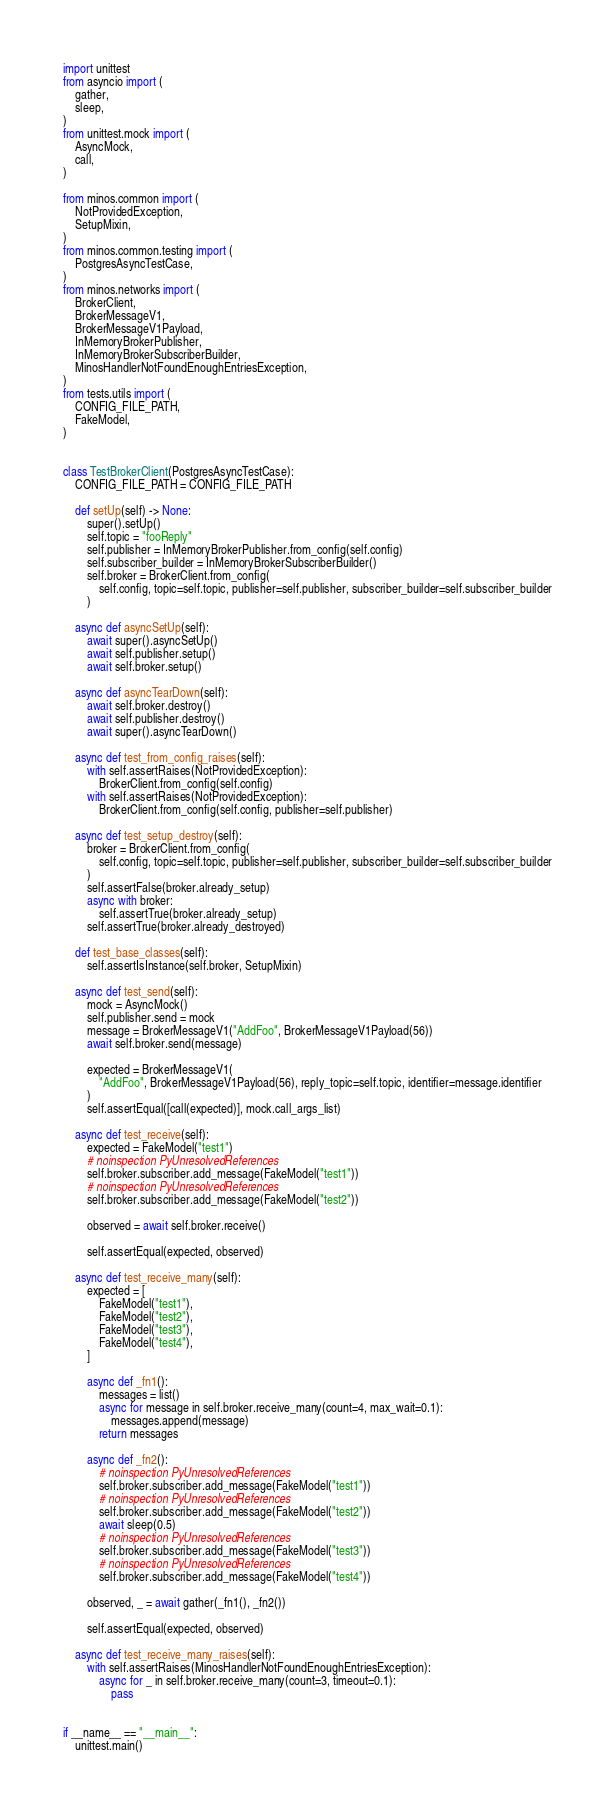<code> <loc_0><loc_0><loc_500><loc_500><_Python_>import unittest
from asyncio import (
    gather,
    sleep,
)
from unittest.mock import (
    AsyncMock,
    call,
)

from minos.common import (
    NotProvidedException,
    SetupMixin,
)
from minos.common.testing import (
    PostgresAsyncTestCase,
)
from minos.networks import (
    BrokerClient,
    BrokerMessageV1,
    BrokerMessageV1Payload,
    InMemoryBrokerPublisher,
    InMemoryBrokerSubscriberBuilder,
    MinosHandlerNotFoundEnoughEntriesException,
)
from tests.utils import (
    CONFIG_FILE_PATH,
    FakeModel,
)


class TestBrokerClient(PostgresAsyncTestCase):
    CONFIG_FILE_PATH = CONFIG_FILE_PATH

    def setUp(self) -> None:
        super().setUp()
        self.topic = "fooReply"
        self.publisher = InMemoryBrokerPublisher.from_config(self.config)
        self.subscriber_builder = InMemoryBrokerSubscriberBuilder()
        self.broker = BrokerClient.from_config(
            self.config, topic=self.topic, publisher=self.publisher, subscriber_builder=self.subscriber_builder
        )

    async def asyncSetUp(self):
        await super().asyncSetUp()
        await self.publisher.setup()
        await self.broker.setup()

    async def asyncTearDown(self):
        await self.broker.destroy()
        await self.publisher.destroy()
        await super().asyncTearDown()

    async def test_from_config_raises(self):
        with self.assertRaises(NotProvidedException):
            BrokerClient.from_config(self.config)
        with self.assertRaises(NotProvidedException):
            BrokerClient.from_config(self.config, publisher=self.publisher)

    async def test_setup_destroy(self):
        broker = BrokerClient.from_config(
            self.config, topic=self.topic, publisher=self.publisher, subscriber_builder=self.subscriber_builder
        )
        self.assertFalse(broker.already_setup)
        async with broker:
            self.assertTrue(broker.already_setup)
        self.assertTrue(broker.already_destroyed)

    def test_base_classes(self):
        self.assertIsInstance(self.broker, SetupMixin)

    async def test_send(self):
        mock = AsyncMock()
        self.publisher.send = mock
        message = BrokerMessageV1("AddFoo", BrokerMessageV1Payload(56))
        await self.broker.send(message)

        expected = BrokerMessageV1(
            "AddFoo", BrokerMessageV1Payload(56), reply_topic=self.topic, identifier=message.identifier
        )
        self.assertEqual([call(expected)], mock.call_args_list)

    async def test_receive(self):
        expected = FakeModel("test1")
        # noinspection PyUnresolvedReferences
        self.broker.subscriber.add_message(FakeModel("test1"))
        # noinspection PyUnresolvedReferences
        self.broker.subscriber.add_message(FakeModel("test2"))

        observed = await self.broker.receive()

        self.assertEqual(expected, observed)

    async def test_receive_many(self):
        expected = [
            FakeModel("test1"),
            FakeModel("test2"),
            FakeModel("test3"),
            FakeModel("test4"),
        ]

        async def _fn1():
            messages = list()
            async for message in self.broker.receive_many(count=4, max_wait=0.1):
                messages.append(message)
            return messages

        async def _fn2():
            # noinspection PyUnresolvedReferences
            self.broker.subscriber.add_message(FakeModel("test1"))
            # noinspection PyUnresolvedReferences
            self.broker.subscriber.add_message(FakeModel("test2"))
            await sleep(0.5)
            # noinspection PyUnresolvedReferences
            self.broker.subscriber.add_message(FakeModel("test3"))
            # noinspection PyUnresolvedReferences
            self.broker.subscriber.add_message(FakeModel("test4"))

        observed, _ = await gather(_fn1(), _fn2())

        self.assertEqual(expected, observed)

    async def test_receive_many_raises(self):
        with self.assertRaises(MinosHandlerNotFoundEnoughEntriesException):
            async for _ in self.broker.receive_many(count=3, timeout=0.1):
                pass


if __name__ == "__main__":
    unittest.main()
</code> 